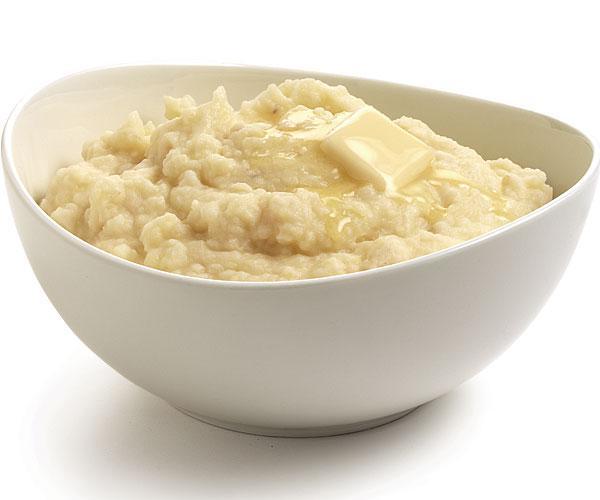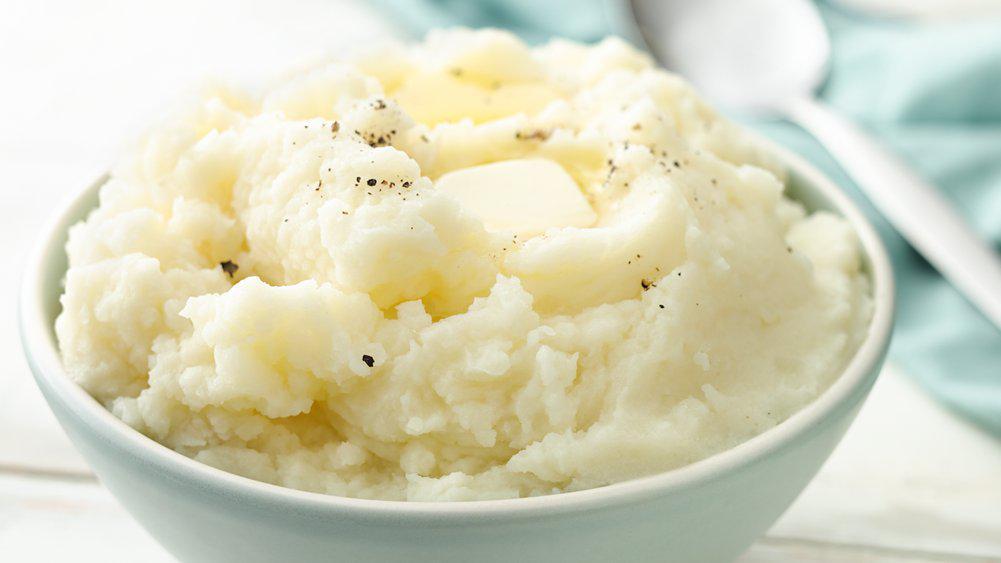The first image is the image on the left, the second image is the image on the right. For the images displayed, is the sentence "A spoon is sitting outside of the bowl of food in one of the images." factually correct? Answer yes or no. Yes. The first image is the image on the left, the second image is the image on the right. Evaluate the accuracy of this statement regarding the images: "There is a spoon laying on the table near the bowl in one image.". Is it true? Answer yes or no. Yes. 